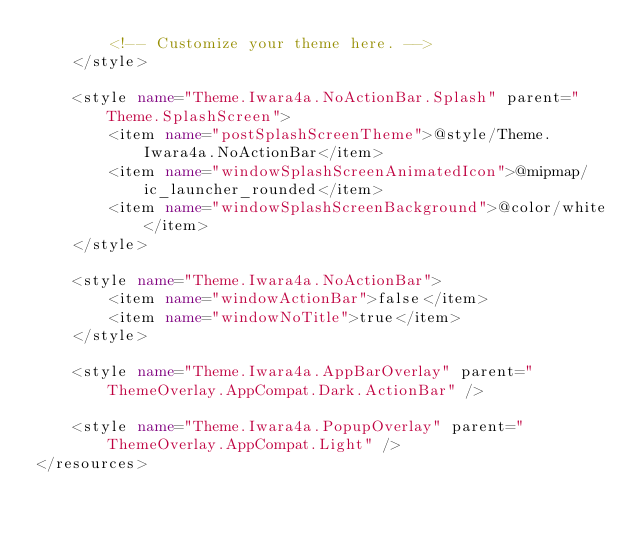<code> <loc_0><loc_0><loc_500><loc_500><_XML_>        <!-- Customize your theme here. -->
    </style>
    
    <style name="Theme.Iwara4a.NoActionBar.Splash" parent="Theme.SplashScreen">
        <item name="postSplashScreenTheme">@style/Theme.Iwara4a.NoActionBar</item>
        <item name="windowSplashScreenAnimatedIcon">@mipmap/ic_launcher_rounded</item>
        <item name="windowSplashScreenBackground">@color/white</item>
    </style>

    <style name="Theme.Iwara4a.NoActionBar">
        <item name="windowActionBar">false</item>
        <item name="windowNoTitle">true</item>
    </style>

    <style name="Theme.Iwara4a.AppBarOverlay" parent="ThemeOverlay.AppCompat.Dark.ActionBar" />

    <style name="Theme.Iwara4a.PopupOverlay" parent="ThemeOverlay.AppCompat.Light" />
</resources></code> 